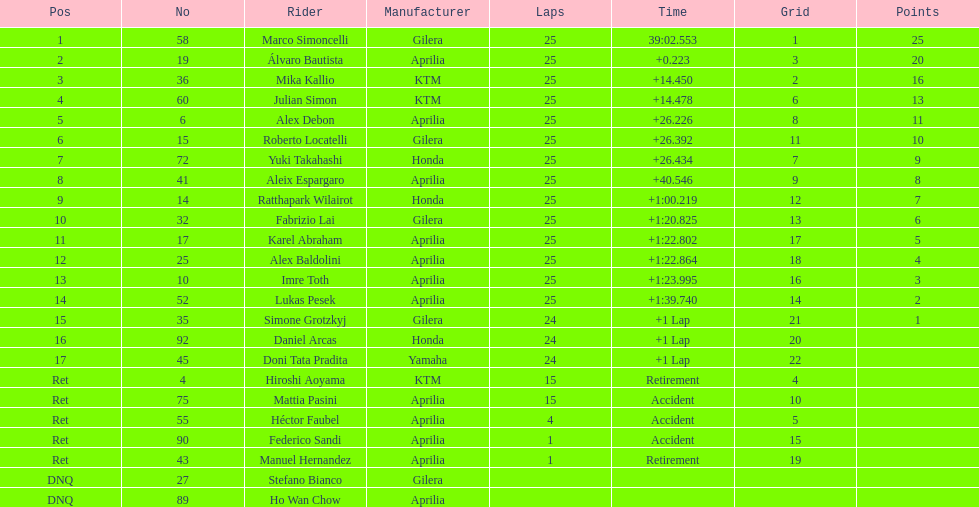Who was the other italian rider after the victor marco simoncelli? Roberto Locatelli. 